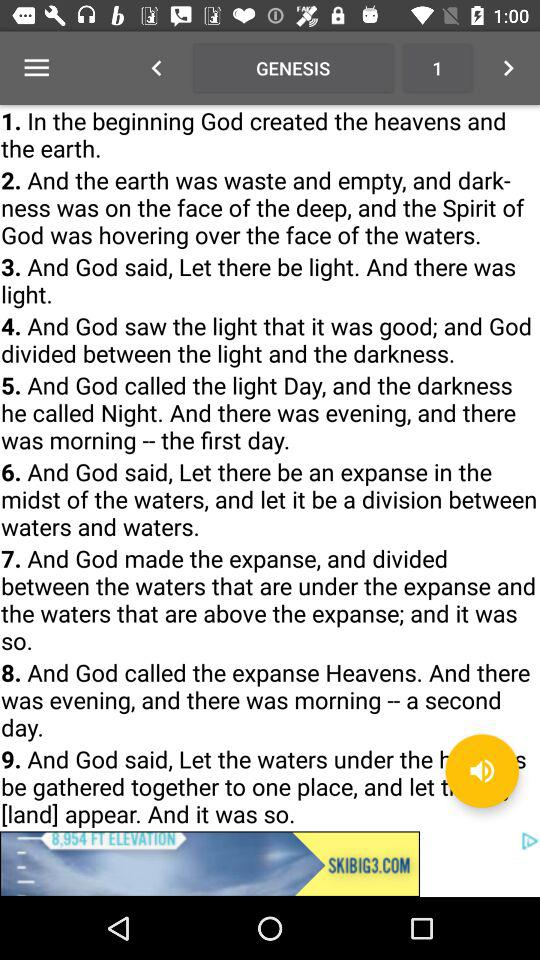How do I go to the next page?
When the provided information is insufficient, respond with <no answer>. <no answer> 